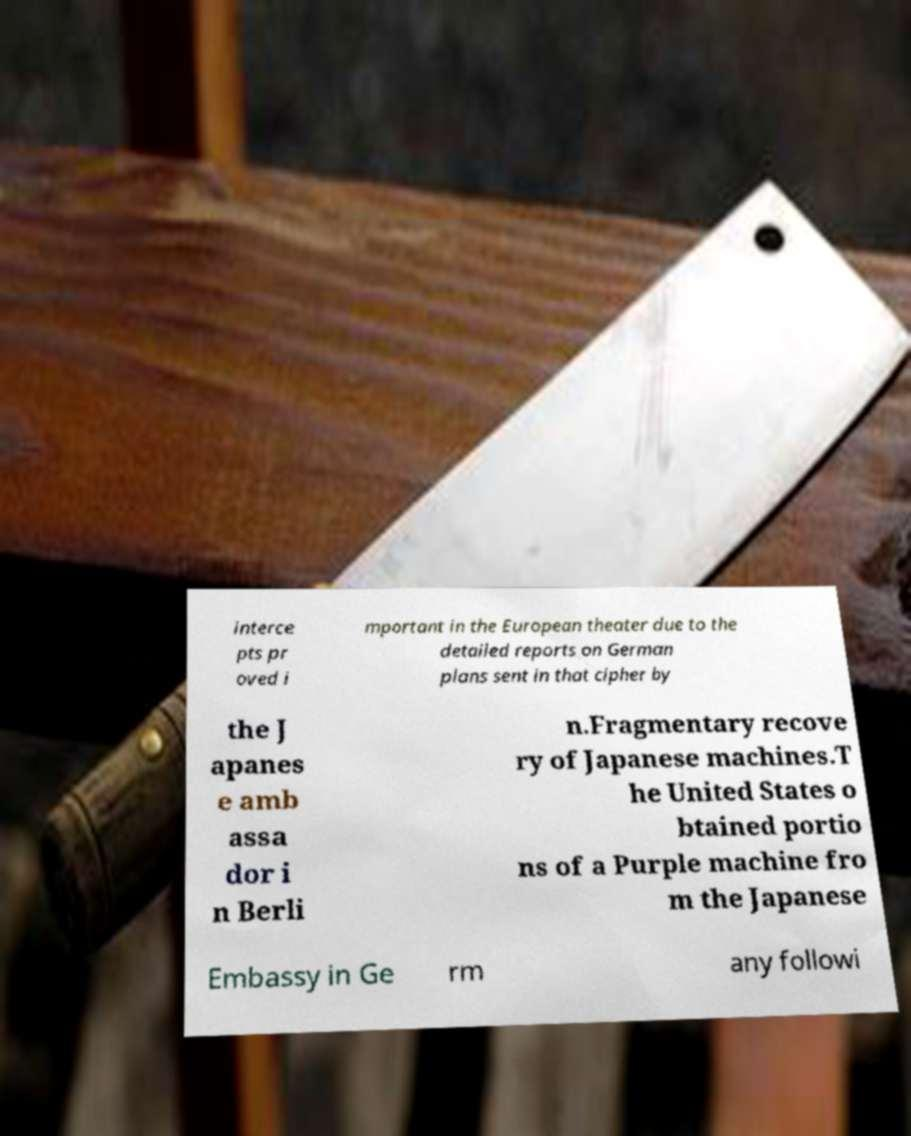Please read and relay the text visible in this image. What does it say? interce pts pr oved i mportant in the European theater due to the detailed reports on German plans sent in that cipher by the J apanes e amb assa dor i n Berli n.Fragmentary recove ry of Japanese machines.T he United States o btained portio ns of a Purple machine fro m the Japanese Embassy in Ge rm any followi 